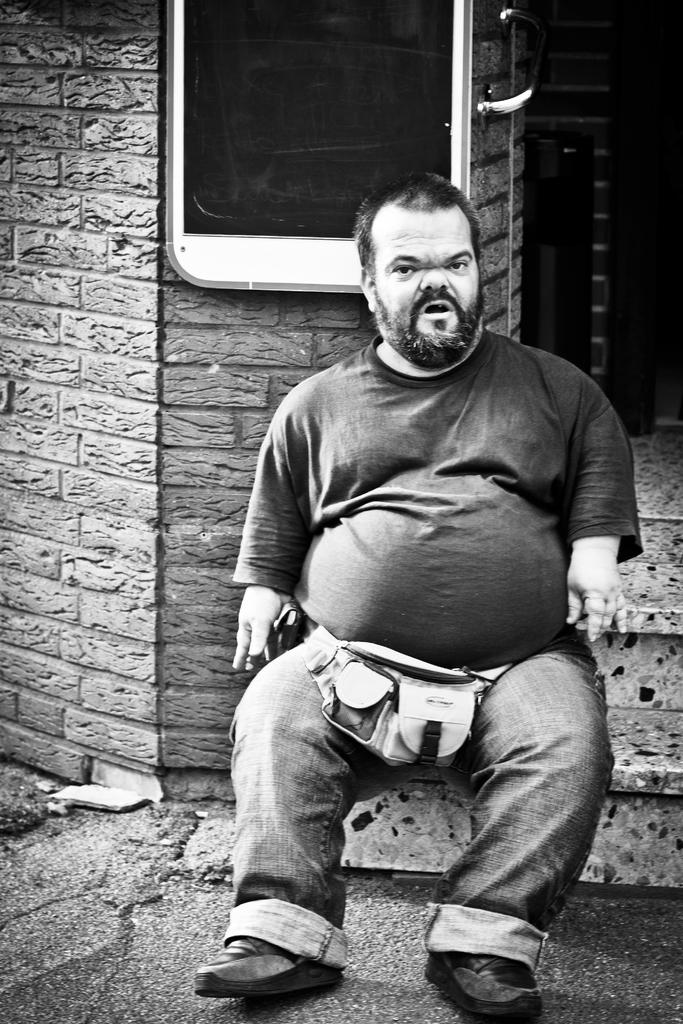What is the color scheme of the image? The image is black and white. What can be seen in the image besides the wall? There is a person sitting on the stairs in the image. What is attached to the wall in the image? There is a board attached to the wall in the image. Can you tell me how many fangs the person sitting on the stairs has in the image? There are no fangs visible in the image, as it features a person sitting on the stairs and a board attached to the wall. 